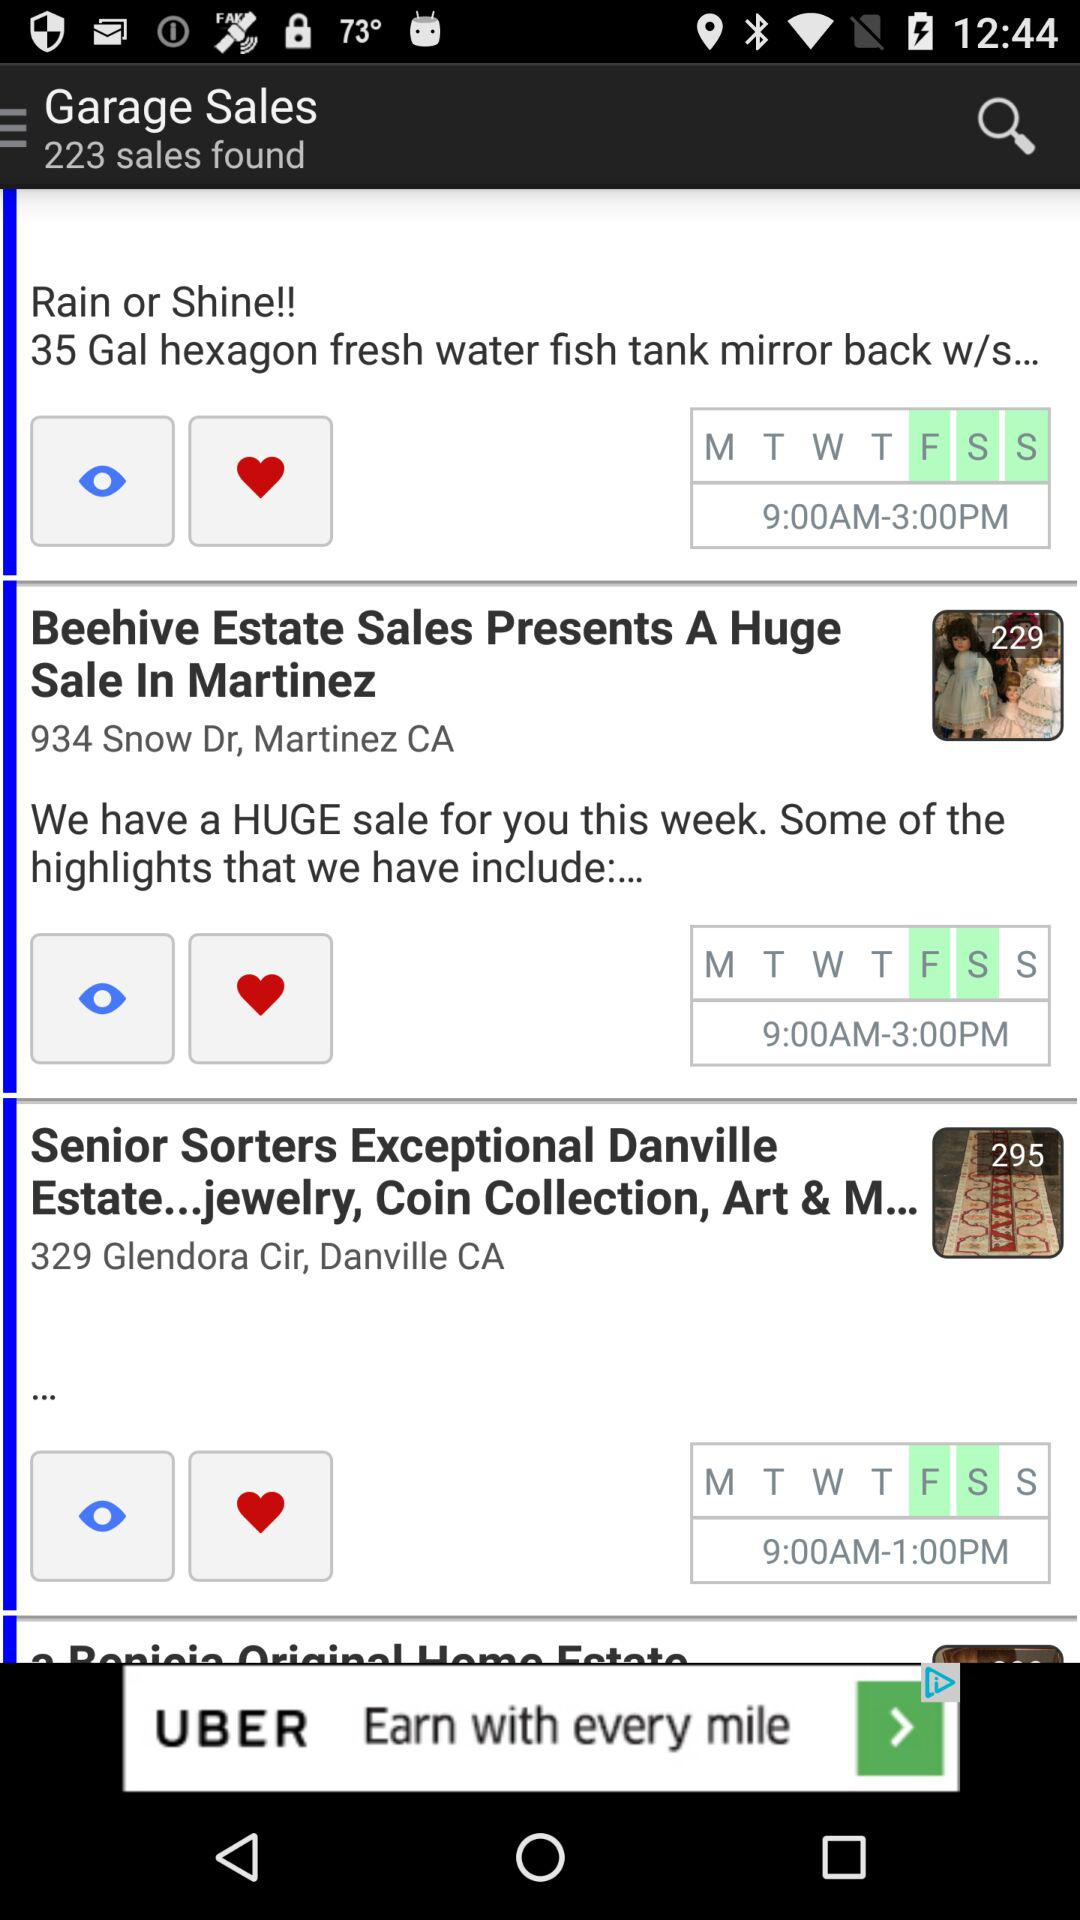What is the count of images for "Senior Sorters"? The count of images is 295. 